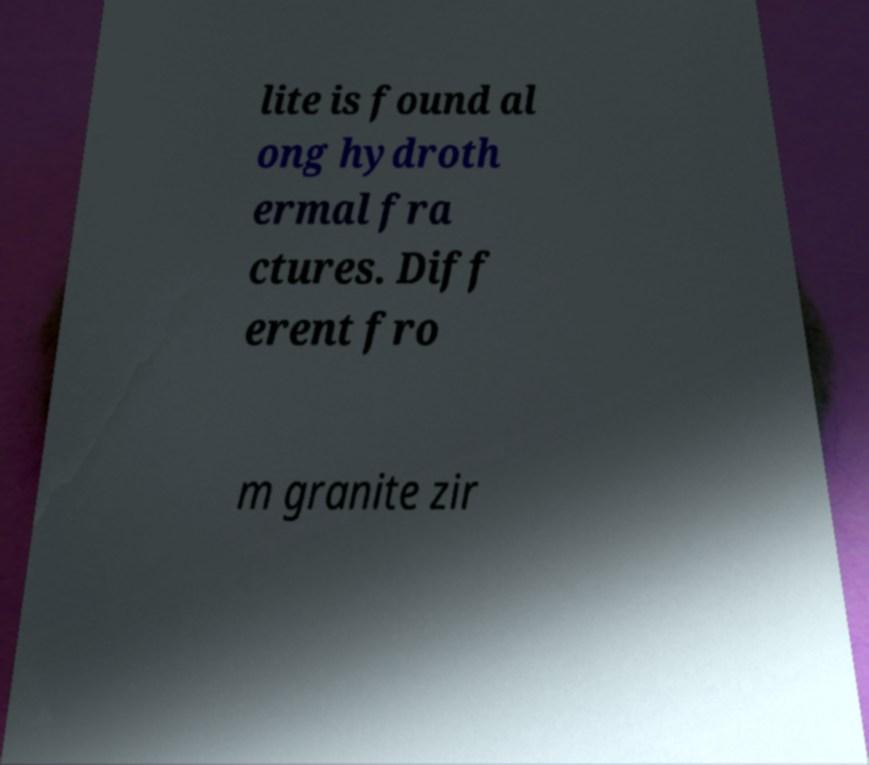Please identify and transcribe the text found in this image. lite is found al ong hydroth ermal fra ctures. Diff erent fro m granite zir 